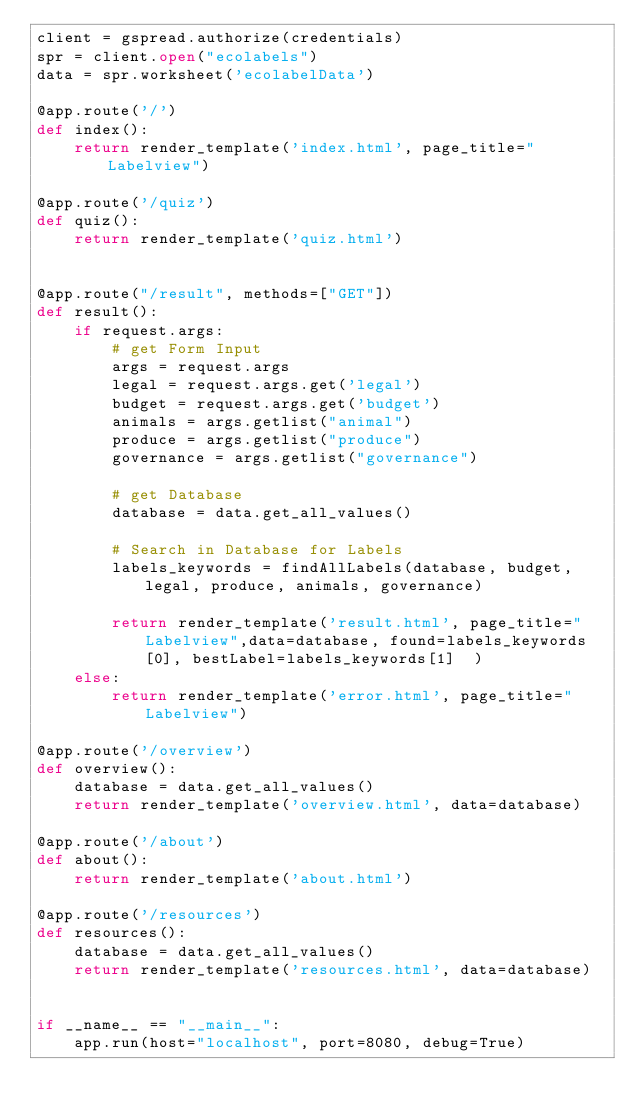Convert code to text. <code><loc_0><loc_0><loc_500><loc_500><_Python_>client = gspread.authorize(credentials)
spr = client.open("ecolabels")
data = spr.worksheet('ecolabelData')

@app.route('/')
def index():
    return render_template('index.html', page_title="Labelview")

@app.route('/quiz')
def quiz():
    return render_template('quiz.html')


@app.route("/result", methods=["GET"])
def result():
    if request.args:
        # get Form Input
        args = request.args
        legal = request.args.get('legal')
        budget = request.args.get('budget')
        animals = args.getlist("animal")
        produce = args.getlist("produce")
        governance = args.getlist("governance")

        # get Database
        database = data.get_all_values()
        
        # Search in Database for Labels
        labels_keywords = findAllLabels(database, budget, legal, produce, animals, governance)
        
        return render_template('result.html', page_title="Labelview",data=database, found=labels_keywords[0], bestLabel=labels_keywords[1]  )
    else:
        return render_template('error.html', page_title="Labelview")

@app.route('/overview')
def overview():
    database = data.get_all_values()
    return render_template('overview.html', data=database)

@app.route('/about')
def about():
    return render_template('about.html')

@app.route('/resources')
def resources():
    database = data.get_all_values()
    return render_template('resources.html', data=database)


if __name__ == "__main__":
    app.run(host="localhost", port=8080, debug=True)

</code> 